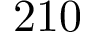<formula> <loc_0><loc_0><loc_500><loc_500>2 1 0</formula> 